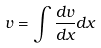<formula> <loc_0><loc_0><loc_500><loc_500>v = \int \frac { d v } { d x } d x</formula> 